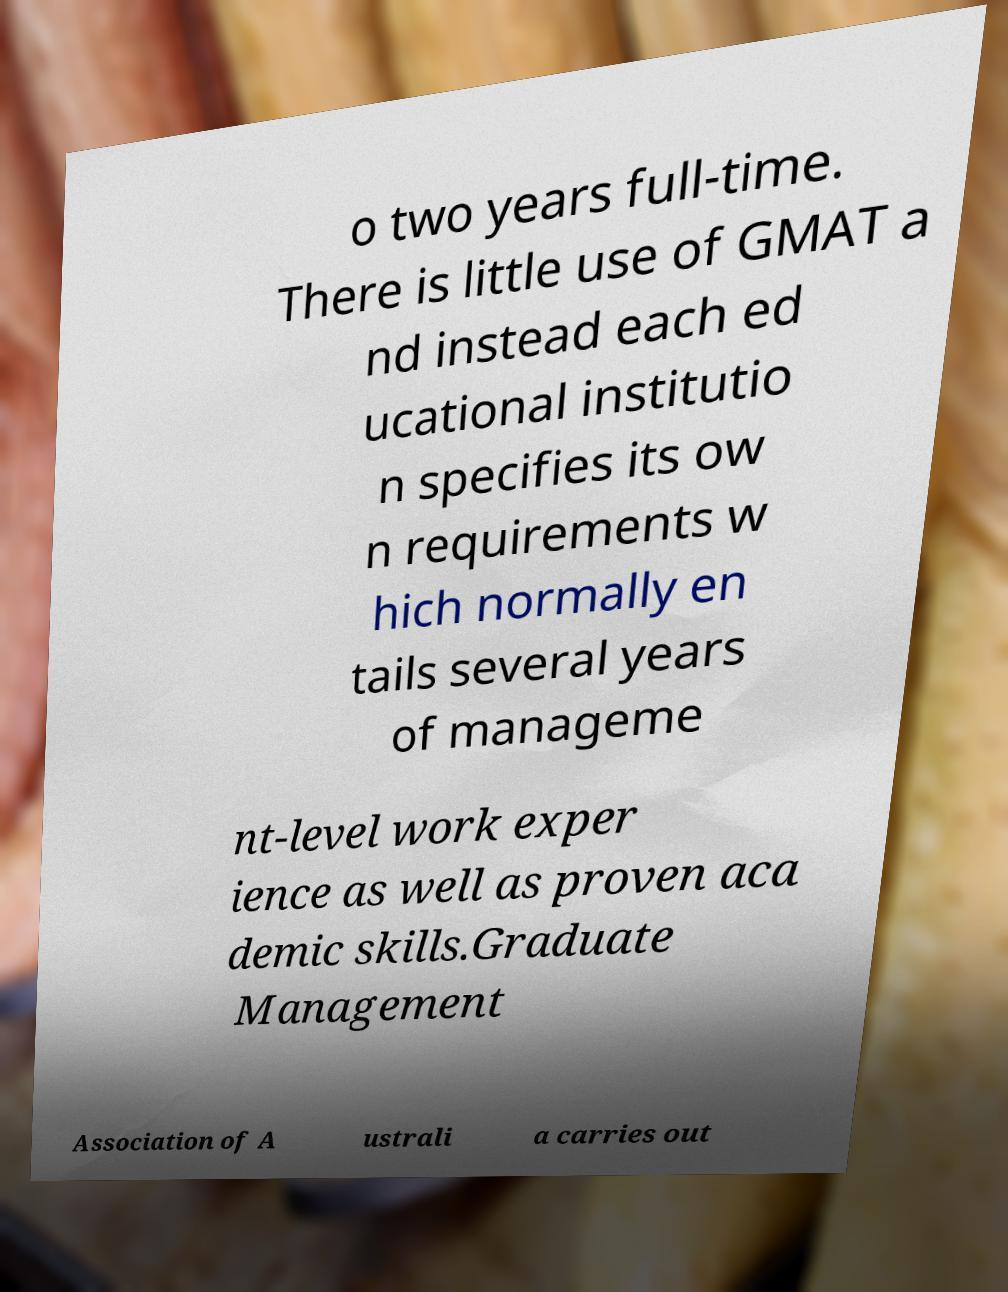Could you assist in decoding the text presented in this image and type it out clearly? o two years full-time. There is little use of GMAT a nd instead each ed ucational institutio n specifies its ow n requirements w hich normally en tails several years of manageme nt-level work exper ience as well as proven aca demic skills.Graduate Management Association of A ustrali a carries out 